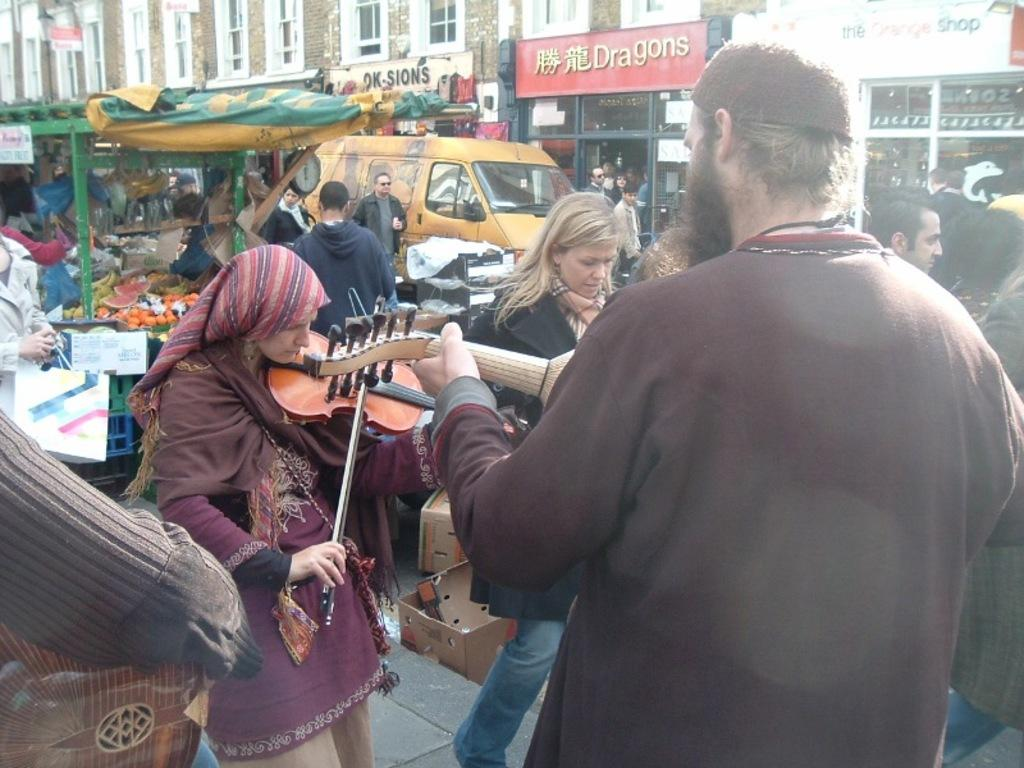What type of structures can be seen in the image? There are buildings in the image. What type of establishments can be found within these structures? There are stores in the image. How many people are present in the image? There are many people in the image. What activity are some of the people engaged in? Some people are playing musical instruments. What type of transportation can be seen in the image? There are vehicles in the image. What type of nerve can be seen in the image? There is no nerve present in the image. 